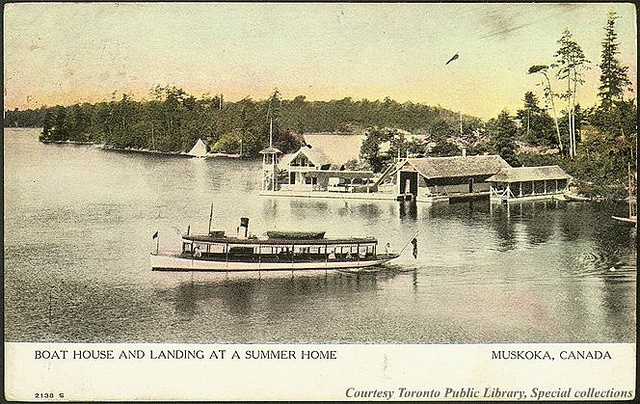Describe the objects in this image and their specific colors. I can see boat in black, ivory, tan, and gray tones, people in black, white, darkgray, and gray tones, people in black, beige, tan, and darkgray tones, bird in black, tan, gray, and beige tones, and people in black, white, gray, and tan tones in this image. 